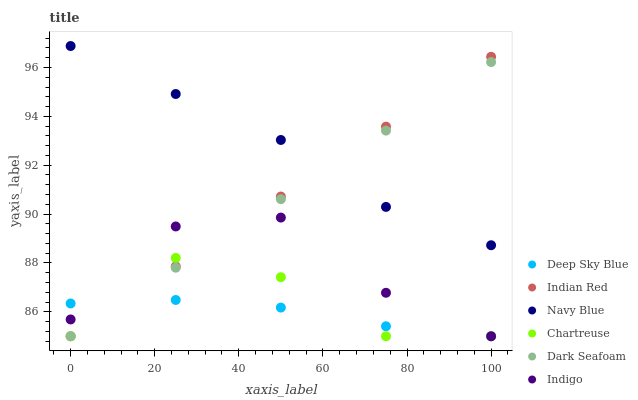Does Deep Sky Blue have the minimum area under the curve?
Answer yes or no. Yes. Does Navy Blue have the maximum area under the curve?
Answer yes or no. Yes. Does Navy Blue have the minimum area under the curve?
Answer yes or no. No. Does Deep Sky Blue have the maximum area under the curve?
Answer yes or no. No. Is Dark Seafoam the smoothest?
Answer yes or no. Yes. Is Indigo the roughest?
Answer yes or no. Yes. Is Deep Sky Blue the smoothest?
Answer yes or no. No. Is Deep Sky Blue the roughest?
Answer yes or no. No. Does Indigo have the lowest value?
Answer yes or no. Yes. Does Navy Blue have the lowest value?
Answer yes or no. No. Does Navy Blue have the highest value?
Answer yes or no. Yes. Does Deep Sky Blue have the highest value?
Answer yes or no. No. Is Chartreuse less than Navy Blue?
Answer yes or no. Yes. Is Navy Blue greater than Deep Sky Blue?
Answer yes or no. Yes. Does Deep Sky Blue intersect Indigo?
Answer yes or no. Yes. Is Deep Sky Blue less than Indigo?
Answer yes or no. No. Is Deep Sky Blue greater than Indigo?
Answer yes or no. No. Does Chartreuse intersect Navy Blue?
Answer yes or no. No. 